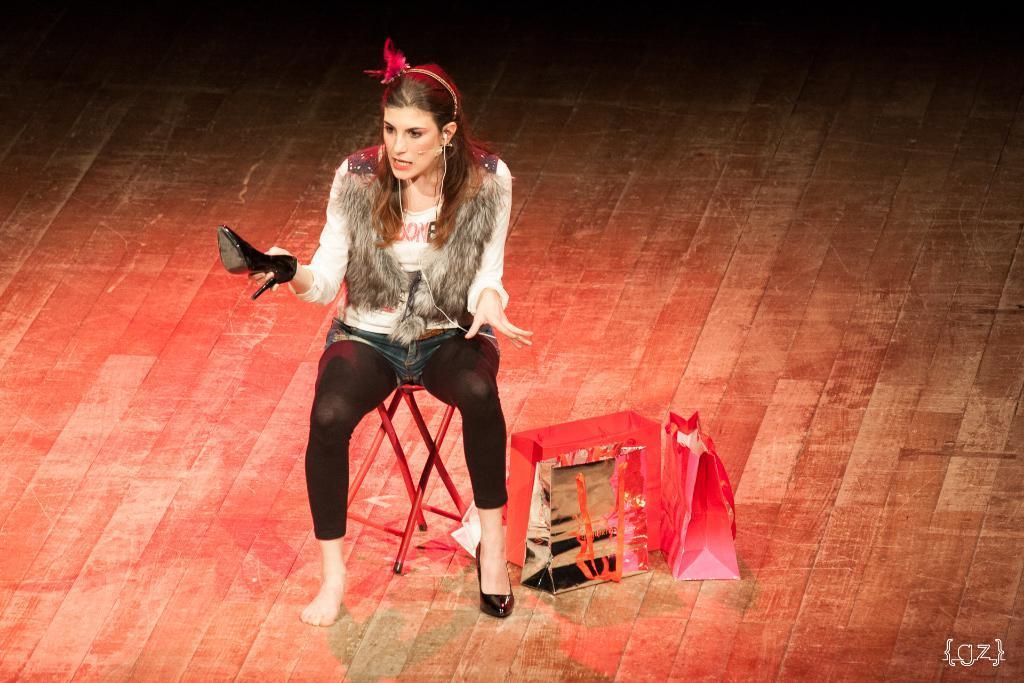In one or two sentences, can you explain what this image depicts? In this image there is a girl sitting on the stool. Beside her there are covers. The woman is holding the shoes. 